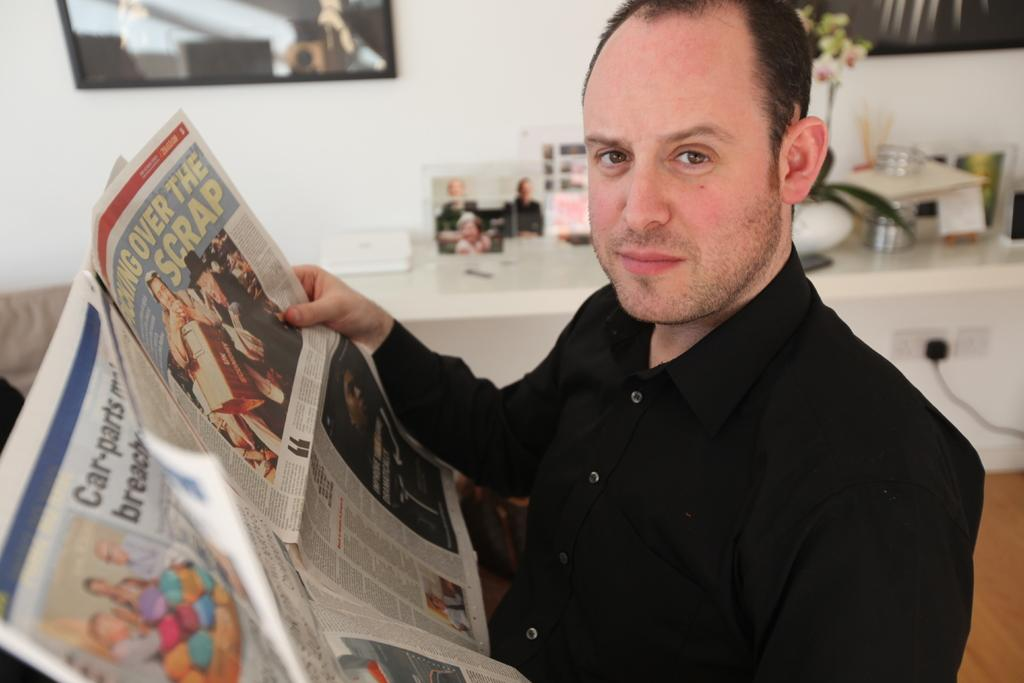Provide a one-sentence caption for the provided image. A man reading a newspaper with the headline over the scrap. 